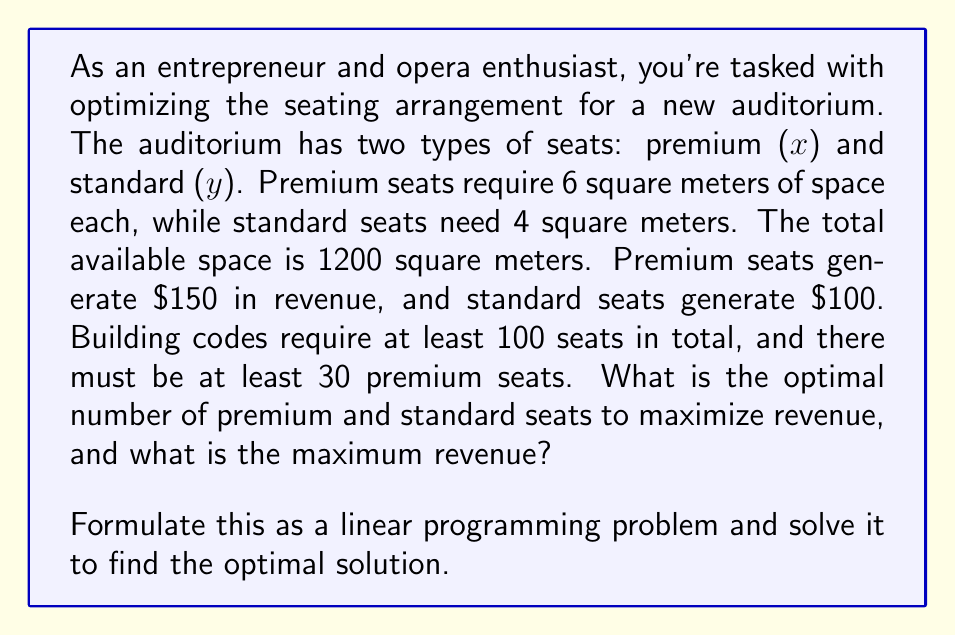Give your solution to this math problem. Let's approach this step-by-step:

1) Define variables:
   $x$ = number of premium seats
   $y$ = number of standard seats

2) Objective function (maximize revenue):
   $\text{Maximize } Z = 150x + 100y$

3) Constraints:
   a) Space constraint: $6x + 4y \leq 1200$
   b) Total seats constraint: $x + y \geq 100$
   c) Minimum premium seats: $x \geq 30$
   d) Non-negativity: $x \geq 0, y \geq 0$

4) Standard form:
   Maximize $Z = 150x + 100y$
   Subject to:
   $6x + 4y \leq 1200$
   $-x - y \leq -100$
   $-x \leq -30$
   $x, y \geq 0$

5) Solve graphically or using the simplex method. Here, we'll use the corner point method:

   Corner points:
   (30, 0): Z = 4500
   (30, 70): Z = 11500
   (150, 75): Z = 30000
   (200, 0): Z = 30000

6) The optimal solution is at (150, 75) or (200, 0), both yielding maximum revenue of 30000.

7) However, (150, 75) satisfies all constraints while (200, 0) doesn't meet the total seats constraint.

Therefore, the optimal solution is 150 premium seats and 75 standard seats.
Answer: 150 premium seats, 75 standard seats; Maximum revenue: $30,000 